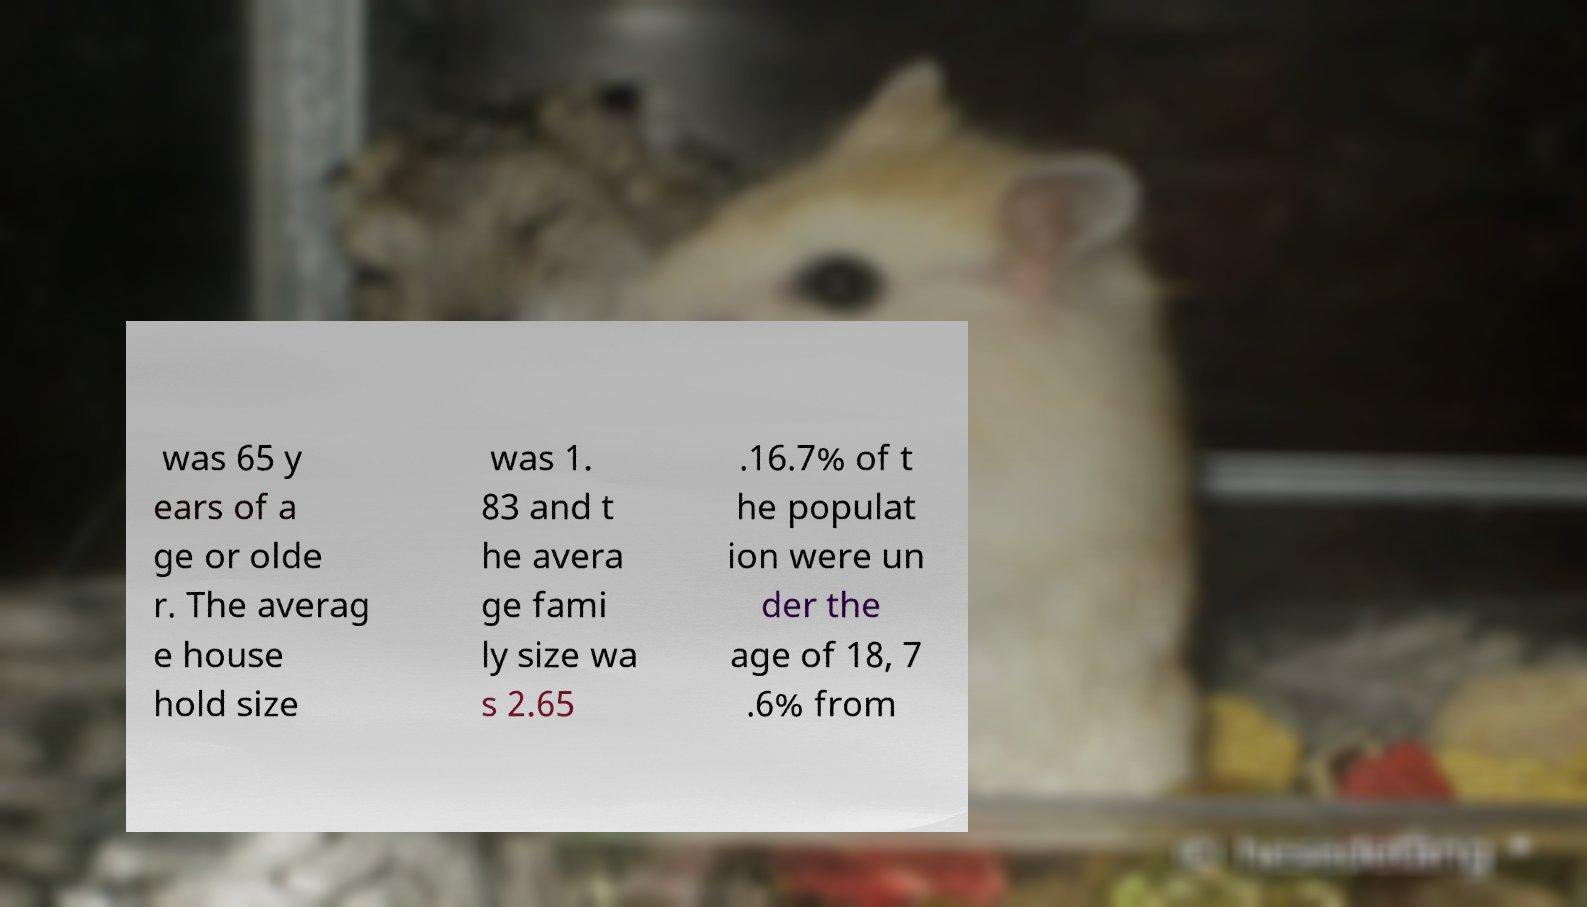Please identify and transcribe the text found in this image. was 65 y ears of a ge or olde r. The averag e house hold size was 1. 83 and t he avera ge fami ly size wa s 2.65 .16.7% of t he populat ion were un der the age of 18, 7 .6% from 